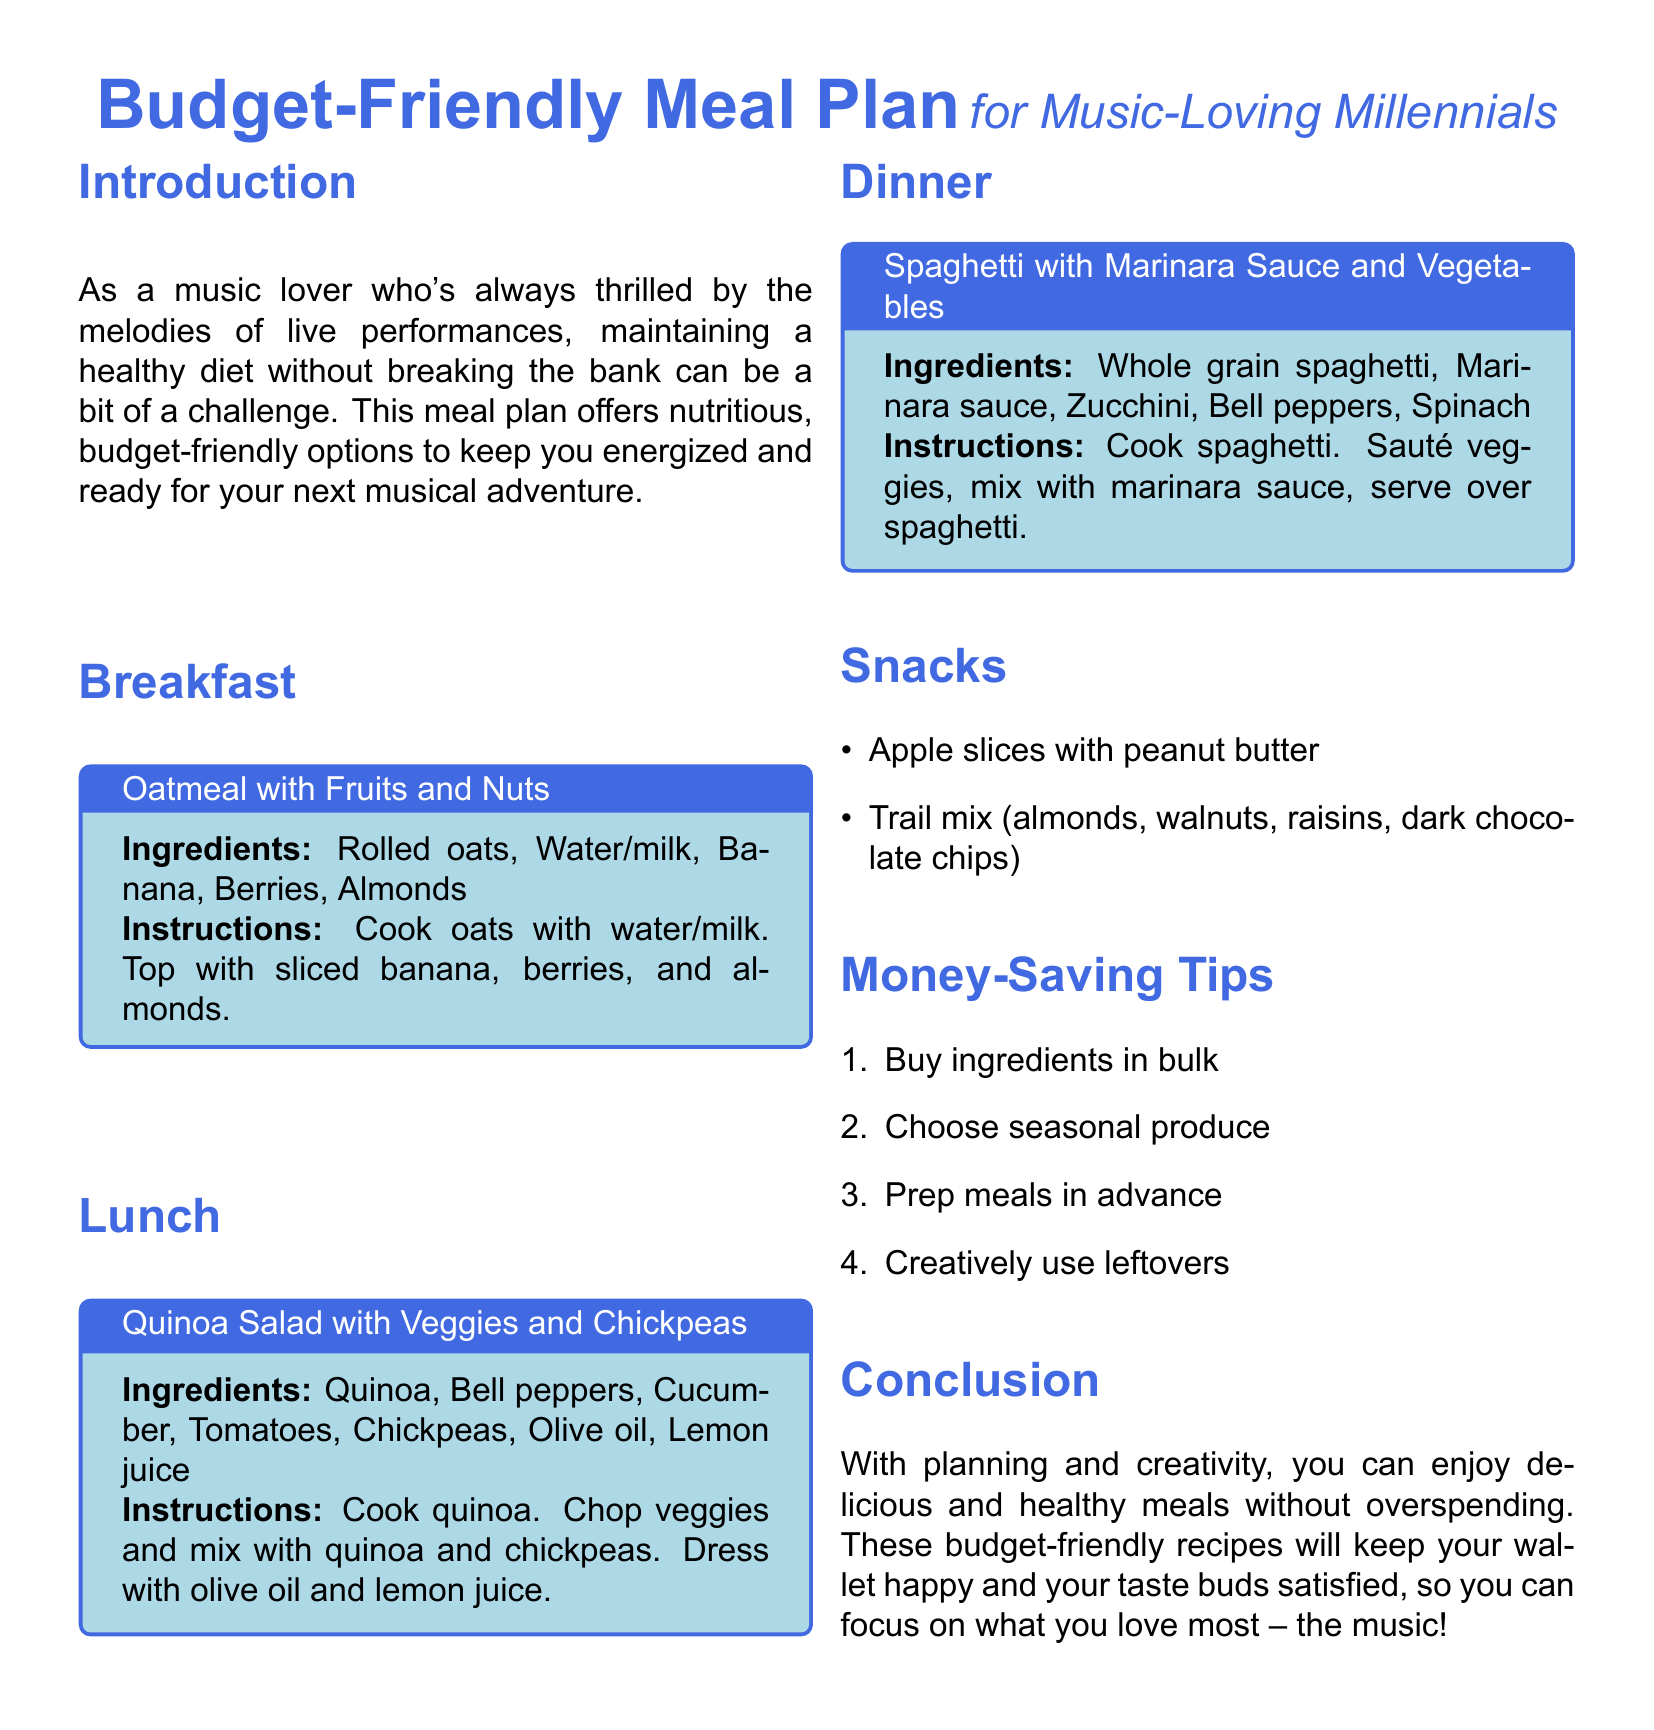what is the title of the meal plan? The title indicates the primary focus and theme of the document for music-loving millennials.
Answer: Budget-Friendly Meal Plan what is one ingredient in the breakfast recipe? The breakfast section lists the components needed for the recipe.
Answer: Rolled oats how many main meals are outlined in the document? The document identifies and lists the primary meals included in the meal plan.
Answer: Three what type of salad is suggested for lunch? The lunch section specifies the name of the salad recipe provided.
Answer: Quinoa Salad with Veggies and Chickpeas which fruit is suggested as a snack? The snack section provides options for healthy snacks included in the meal plan.
Answer: Apple slices what is one tip for saving money on meals? The money-saving tips section offers practical advice for budgeting.
Answer: Buy ingredients in bulk what is the main ingredient in the dinner recipe? The dinner section highlights the key component used in the main dish.
Answer: Whole grain spaghetti how are the vegetables in the dinner recipe prepared before serving? The instructions in the dinner section describe the cooking process for the ingredients.
Answer: Sautéed what is the color theme used in the document? The document employs a specific color palette to highlight areas, especially the title and sections.
Answer: Music blue 